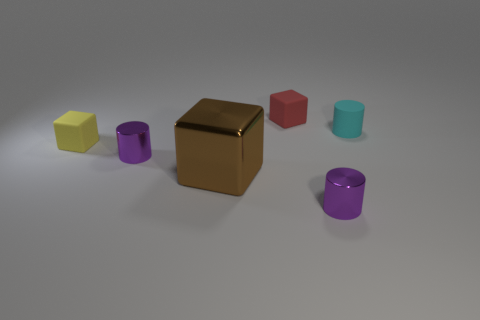There is a small thing that is on the right side of the tiny red cube and behind the brown cube; what shape is it?
Offer a terse response. Cylinder. Are there any cylinders made of the same material as the tiny yellow cube?
Your response must be concise. Yes. Is the material of the object that is in front of the large thing the same as the tiny cube behind the rubber cylinder?
Give a very brief answer. No. Are there more tiny rubber things than big gray things?
Make the answer very short. Yes. What is the color of the matte cube behind the tiny yellow matte object that is to the left of the matte block that is right of the yellow block?
Provide a short and direct response. Red. Do the small rubber thing that is in front of the cyan object and the tiny matte object behind the cyan matte thing have the same color?
Keep it short and to the point. No. What number of brown metallic things are to the right of the small metallic cylinder to the left of the big shiny object?
Offer a terse response. 1. Are any cyan objects visible?
Offer a terse response. Yes. How many other objects are the same color as the tiny rubber cylinder?
Provide a succinct answer. 0. Are there fewer purple metal objects than cylinders?
Offer a very short reply. Yes. 